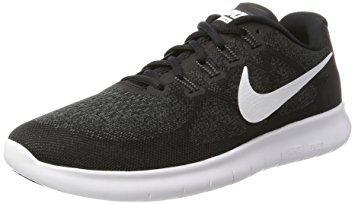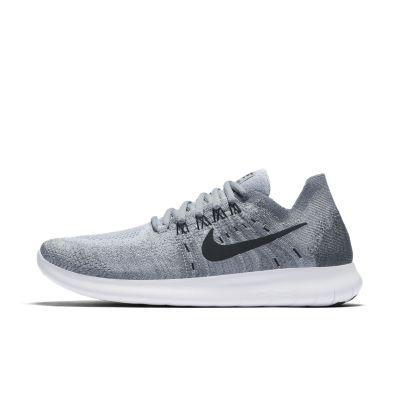The first image is the image on the left, the second image is the image on the right. Examine the images to the left and right. Is the description "There are exactly two shoes shown in one of the images." accurate? Answer yes or no. No. 